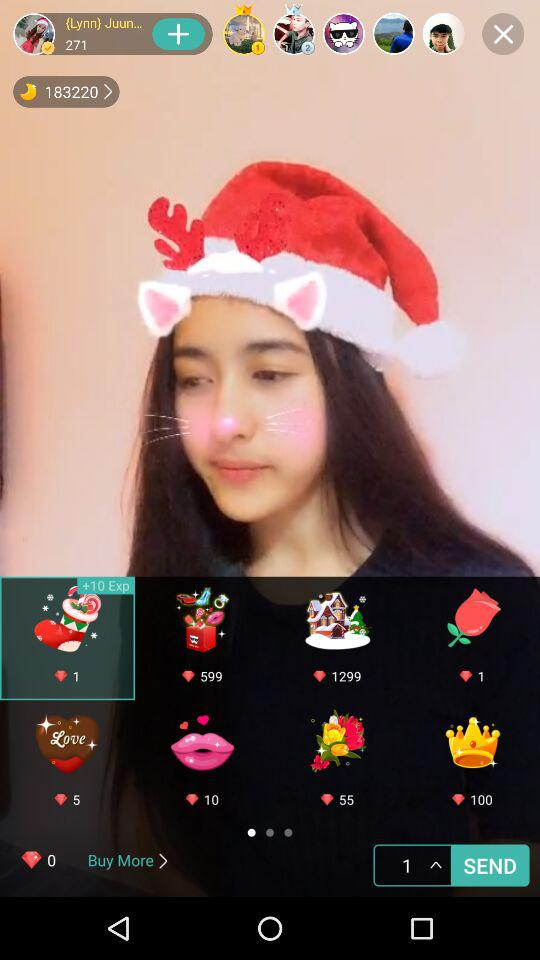What is the user name? The user name is "{Lynn} Juun...". 